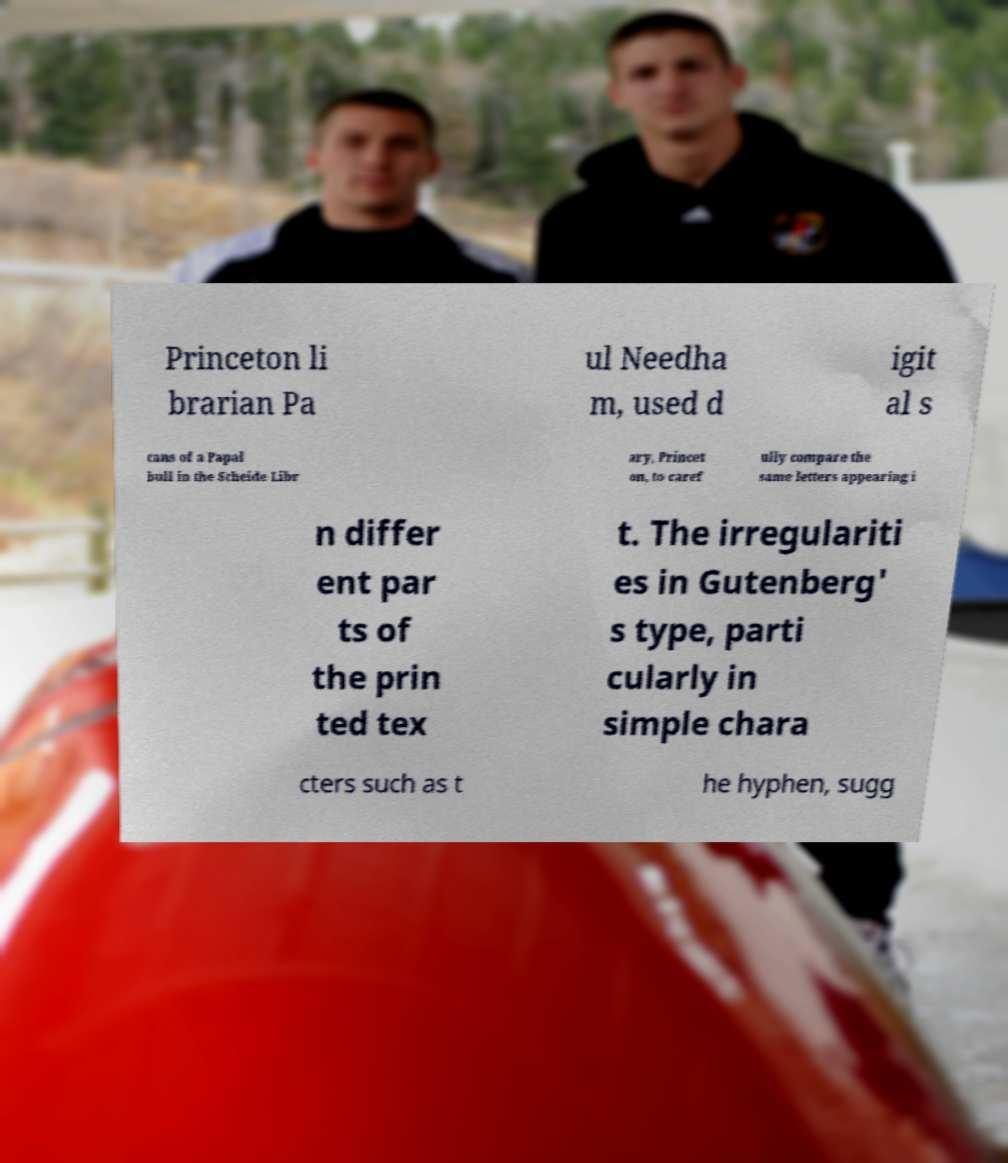There's text embedded in this image that I need extracted. Can you transcribe it verbatim? Princeton li brarian Pa ul Needha m, used d igit al s cans of a Papal bull in the Scheide Libr ary, Princet on, to caref ully compare the same letters appearing i n differ ent par ts of the prin ted tex t. The irregulariti es in Gutenberg' s type, parti cularly in simple chara cters such as t he hyphen, sugg 